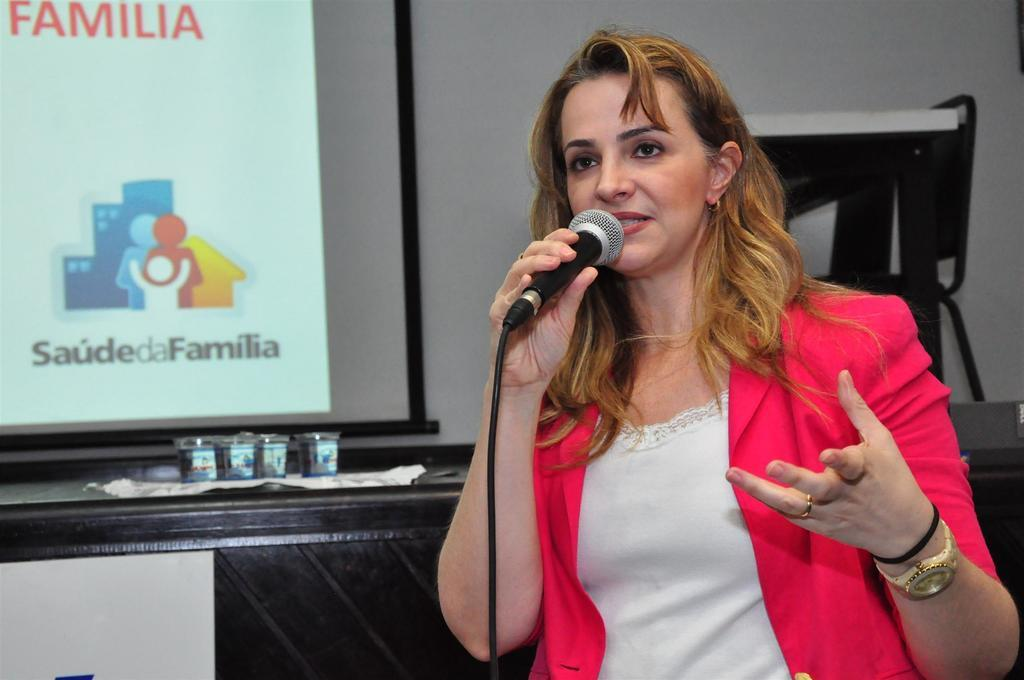Who is the main subject in the image? There is a woman in the image. What is the woman doing in the image? The woman is speaking on a microphone. What can be seen on the left side of the image? There is a screen on the left side of the image. What objects are on the table in the image? There are glasses on a table in the image. What color is the wall behind the woman? There is a white-colored wall behind the woman. What type of summer clothing is the woman wearing in the image? The provided facts do not mention any clothing or the season, so we cannot determine the type of summer clothing the woman is wearing. 